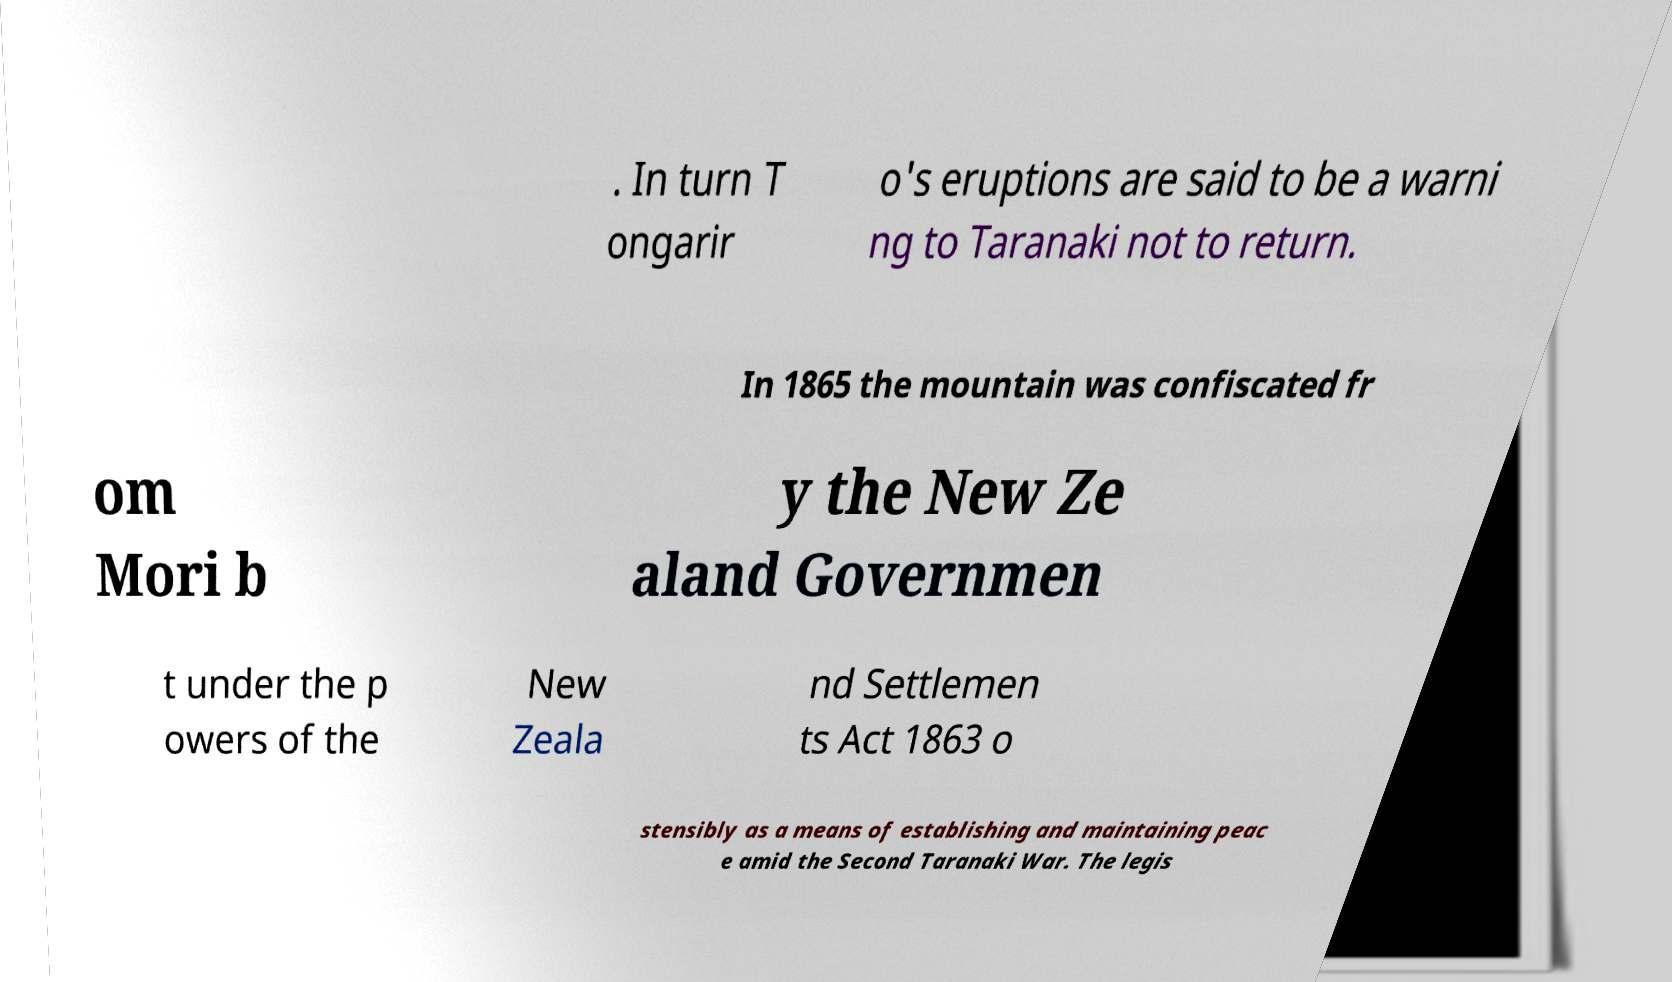For documentation purposes, I need the text within this image transcribed. Could you provide that? . In turn T ongarir o's eruptions are said to be a warni ng to Taranaki not to return. In 1865 the mountain was confiscated fr om Mori b y the New Ze aland Governmen t under the p owers of the New Zeala nd Settlemen ts Act 1863 o stensibly as a means of establishing and maintaining peac e amid the Second Taranaki War. The legis 